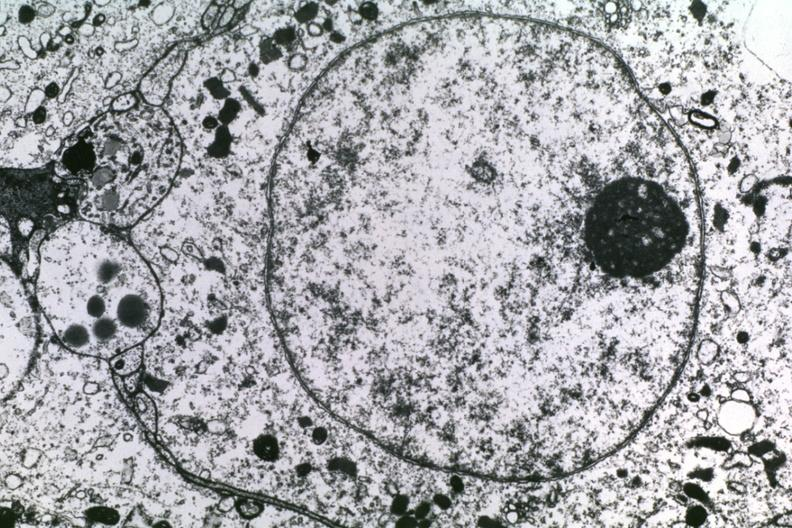s lymphoid atrophy in newborn present?
Answer the question using a single word or phrase. No 